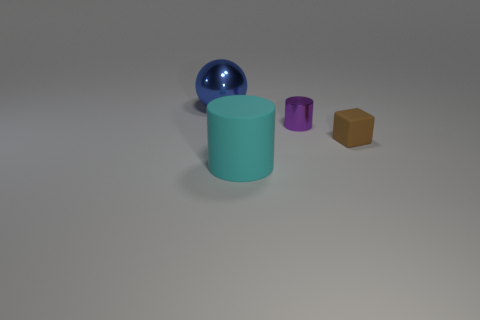Are there any green matte things of the same size as the purple metal cylinder?
Offer a terse response. No. There is a cylinder that is to the left of the metallic cylinder; what is its color?
Offer a very short reply. Cyan. There is a thing that is behind the large cylinder and left of the purple shiny object; what is its shape?
Offer a terse response. Sphere. How many other metal things are the same shape as the cyan thing?
Offer a terse response. 1. How many big objects are there?
Give a very brief answer. 2. What is the size of the object that is to the right of the sphere and to the left of the purple metallic thing?
Ensure brevity in your answer.  Large. There is a cyan object that is the same size as the blue metal ball; what shape is it?
Ensure brevity in your answer.  Cylinder. There is a cyan object in front of the brown matte object; is there a small brown rubber cube in front of it?
Keep it short and to the point. No. What is the color of the other thing that is the same shape as the tiny shiny thing?
Ensure brevity in your answer.  Cyan. There is a matte thing right of the purple object; does it have the same color as the large matte cylinder?
Your answer should be compact. No. 